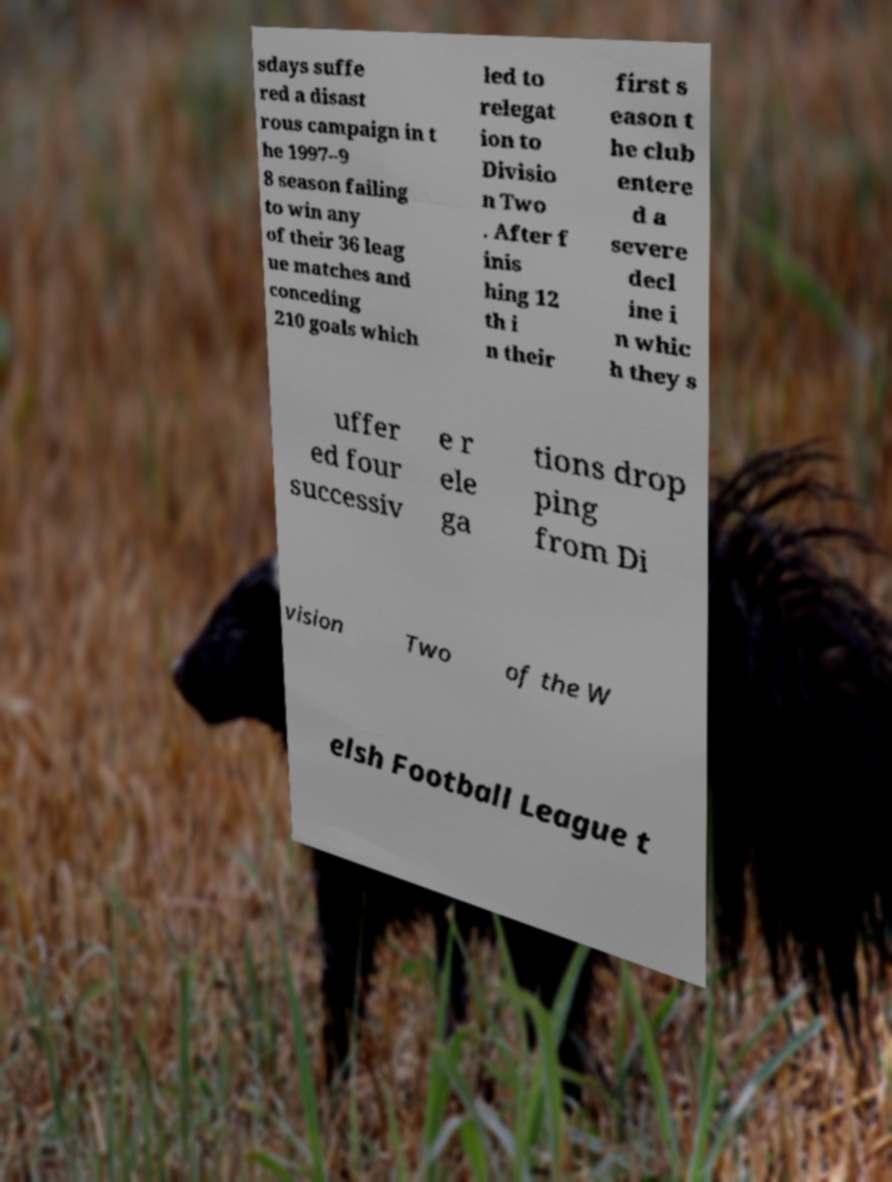Please read and relay the text visible in this image. What does it say? sdays suffe red a disast rous campaign in t he 1997–9 8 season failing to win any of their 36 leag ue matches and conceding 210 goals which led to relegat ion to Divisio n Two . After f inis hing 12 th i n their first s eason t he club entere d a severe decl ine i n whic h they s uffer ed four successiv e r ele ga tions drop ping from Di vision Two of the W elsh Football League t 